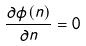<formula> <loc_0><loc_0><loc_500><loc_500>\frac { \partial \phi ( n ) } { \partial n } = 0</formula> 